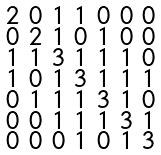Convert formula to latex. <formula><loc_0><loc_0><loc_500><loc_500>\begin{smallmatrix} 2 & 0 & 1 & 1 & 0 & 0 & 0 \\ 0 & 2 & 1 & 0 & 1 & 0 & 0 \\ 1 & 1 & 3 & 1 & 1 & 1 & 0 \\ 1 & 0 & 1 & 3 & 1 & 1 & 1 \\ 0 & 1 & 1 & 1 & 3 & 1 & 0 \\ 0 & 0 & 1 & 1 & 1 & 3 & 1 \\ 0 & 0 & 0 & 1 & 0 & 1 & 3 \end{smallmatrix}</formula> 